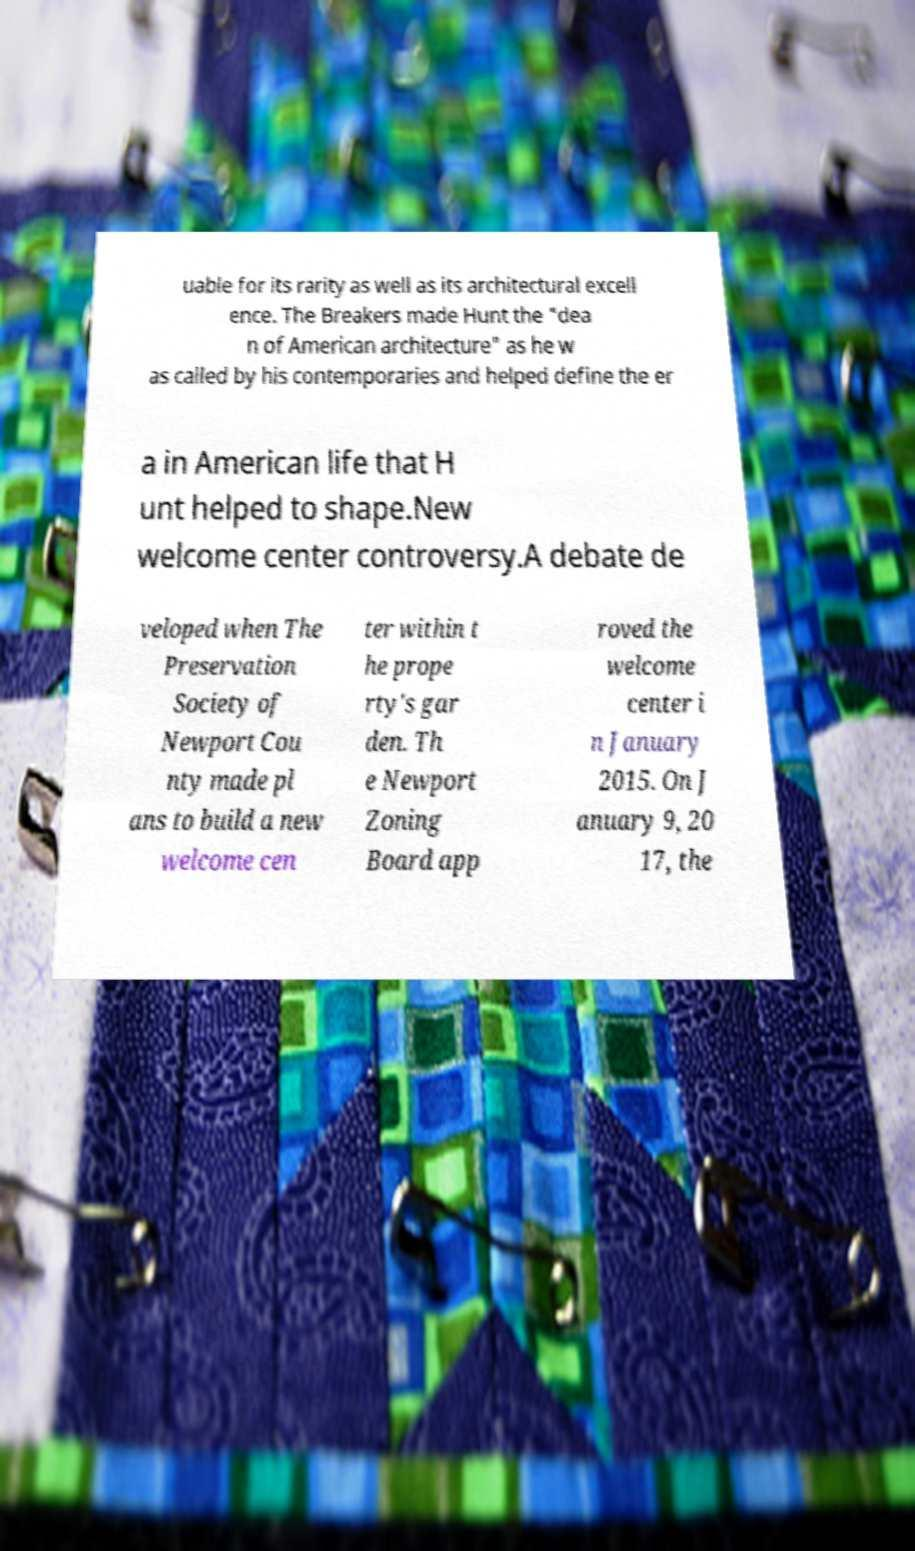Can you accurately transcribe the text from the provided image for me? uable for its rarity as well as its architectural excell ence. The Breakers made Hunt the "dea n of American architecture" as he w as called by his contemporaries and helped define the er a in American life that H unt helped to shape.New welcome center controversy.A debate de veloped when The Preservation Society of Newport Cou nty made pl ans to build a new welcome cen ter within t he prope rty's gar den. Th e Newport Zoning Board app roved the welcome center i n January 2015. On J anuary 9, 20 17, the 